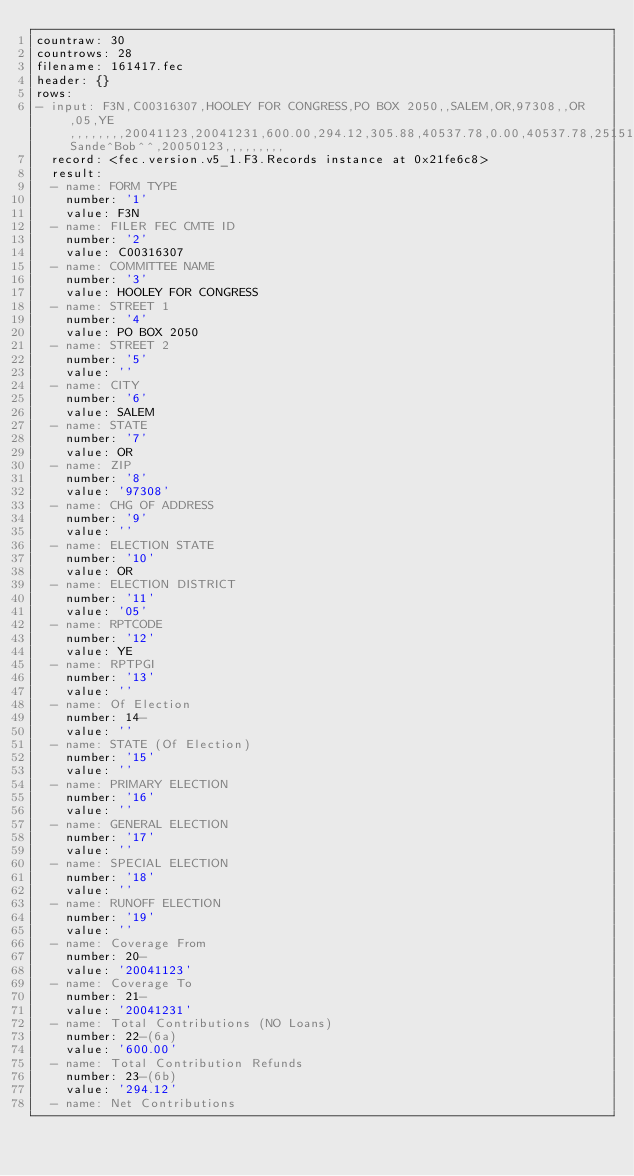Convert code to text. <code><loc_0><loc_0><loc_500><loc_500><_YAML_>countraw: 30
countrows: 28
filename: 161417.fec
header: {}
rows:
- input: F3N,C00316307,HOOLEY FOR CONGRESS,PO BOX 2050,,SALEM,OR,97308,,OR,05,YE,,,,,,,,20041123,20041231,600.00,294.12,305.88,40537.78,0.00,40537.78,251515.31,0.00,0.00,0.00,600.00,600.00,0.00,0.00,0.00,600.00,0.00,0.00,0.00,0.00,0.00,147.15,747.15,40537.78,0.00,0.00,0.00,0.00,0.00,0.00,294.12,294.12,0.00,40831.90,291600.06,747.15,292347.21,40831.90,251515.31,1750.00,294.12,1455.88,45972.83,0.00,45972.83,1000.00,750.00,1750.00,0.00,0.00,0.00,1750.00,0.00,0.00,0.00,0.00,0.00,147.15,1897.15,45972.83,0.00,0.00,0.00,0.00,0.00,0.00,294.12,294.12,0.00,46266.95,Sande^Bob^^,20050123,,,,,,,,,
  record: <fec.version.v5_1.F3.Records instance at 0x21fe6c8>
  result:
  - name: FORM TYPE
    number: '1'
    value: F3N
  - name: FILER FEC CMTE ID
    number: '2'
    value: C00316307
  - name: COMMITTEE NAME
    number: '3'
    value: HOOLEY FOR CONGRESS
  - name: STREET 1
    number: '4'
    value: PO BOX 2050
  - name: STREET 2
    number: '5'
    value: ''
  - name: CITY
    number: '6'
    value: SALEM
  - name: STATE
    number: '7'
    value: OR
  - name: ZIP
    number: '8'
    value: '97308'
  - name: CHG OF ADDRESS
    number: '9'
    value: ''
  - name: ELECTION STATE
    number: '10'
    value: OR
  - name: ELECTION DISTRICT
    number: '11'
    value: '05'
  - name: RPTCODE
    number: '12'
    value: YE
  - name: RPTPGI
    number: '13'
    value: ''
  - name: Of Election
    number: 14-
    value: ''
  - name: STATE (Of Election)
    number: '15'
    value: ''
  - name: PRIMARY ELECTION
    number: '16'
    value: ''
  - name: GENERAL ELECTION
    number: '17'
    value: ''
  - name: SPECIAL ELECTION
    number: '18'
    value: ''
  - name: RUNOFF ELECTION
    number: '19'
    value: ''
  - name: Coverage From
    number: 20-
    value: '20041123'
  - name: Coverage To
    number: 21-
    value: '20041231'
  - name: Total Contributions (NO Loans)
    number: 22-(6a)
    value: '600.00'
  - name: Total Contribution Refunds
    number: 23-(6b)
    value: '294.12'
  - name: Net Contributions</code> 